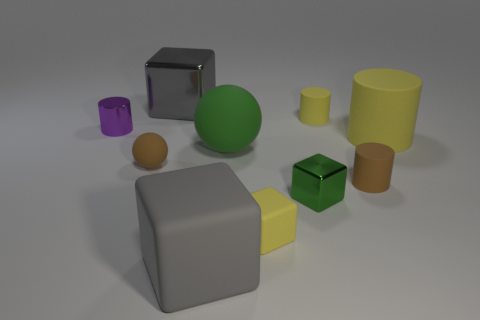What materials do these objects seem to be made of? Based on their appearance, the objects seem to be made of different materials. The shiny, reflective cube appears metallic, while others like the green and the smaller yellow object have a matte finish that could suggest a rubbery material. The remaining objects might be made of plastic given their opaque and non-reflective surface. 